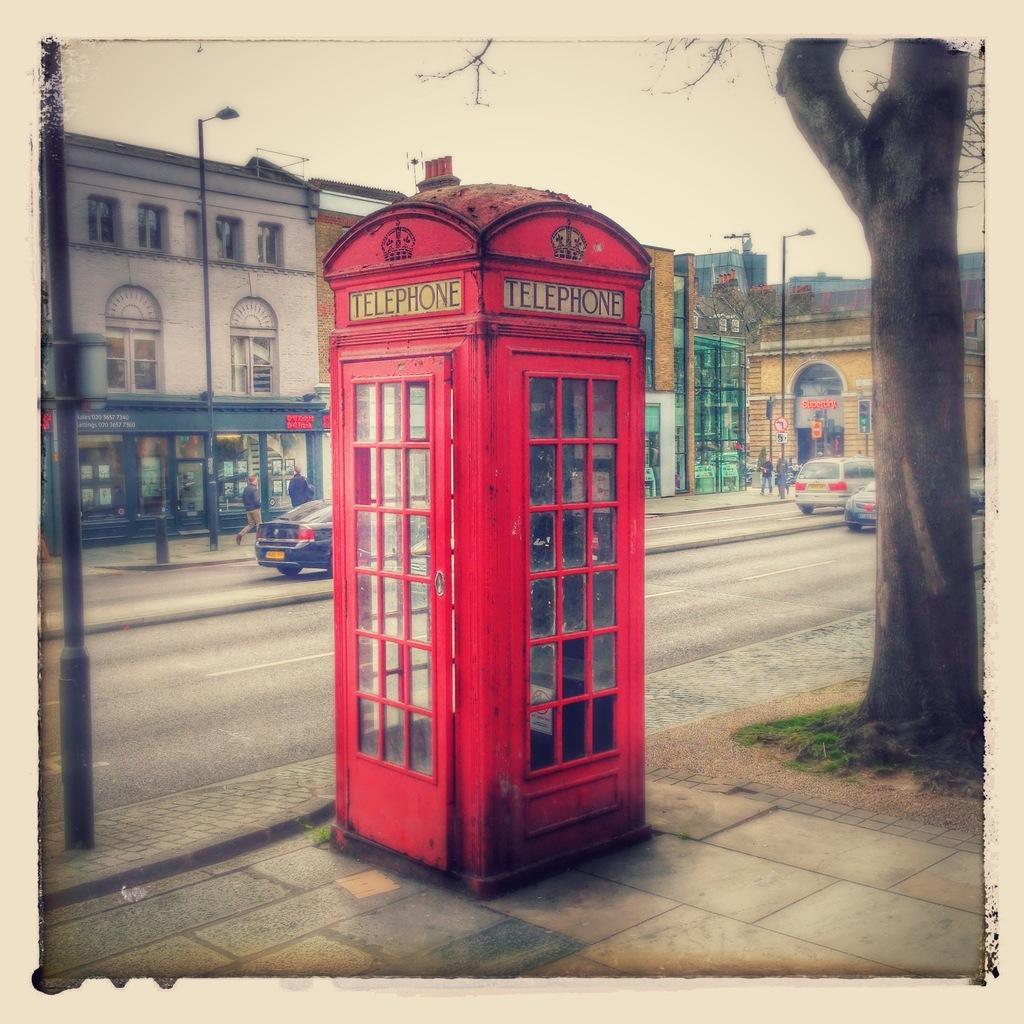Could you give a brief overview of what you see in this image? in this picture we can see a telephone booth here, in the background there are some buildings, we can see poles here, there are some vehicles traveling on the road, we can see people walking here, on the right side there is a tree we can see the sky at the top of the picture. 